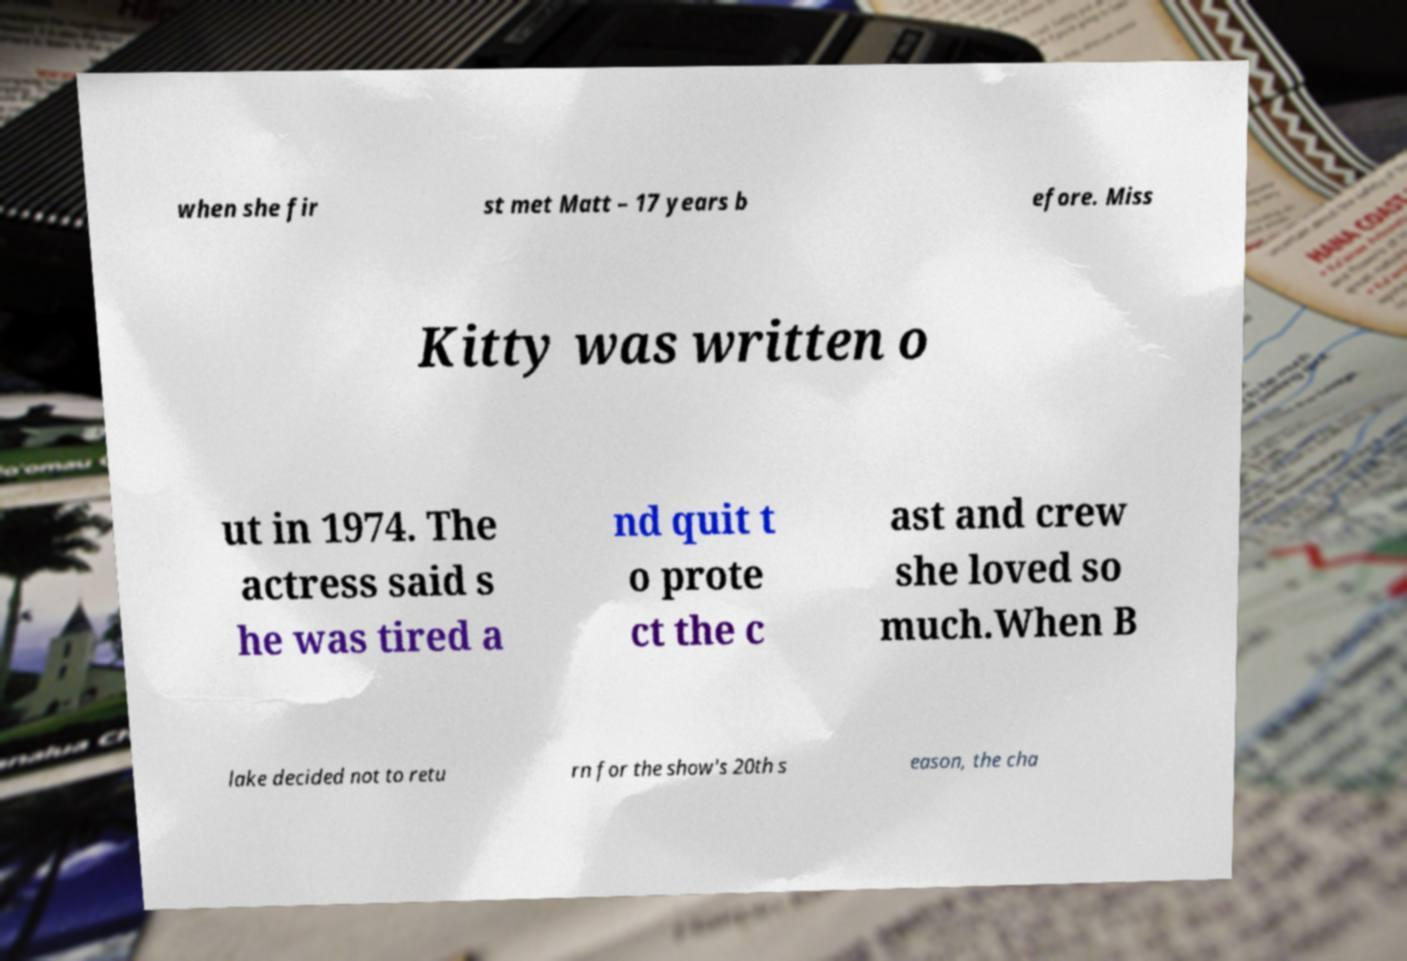Could you extract and type out the text from this image? when she fir st met Matt – 17 years b efore. Miss Kitty was written o ut in 1974. The actress said s he was tired a nd quit t o prote ct the c ast and crew she loved so much.When B lake decided not to retu rn for the show's 20th s eason, the cha 